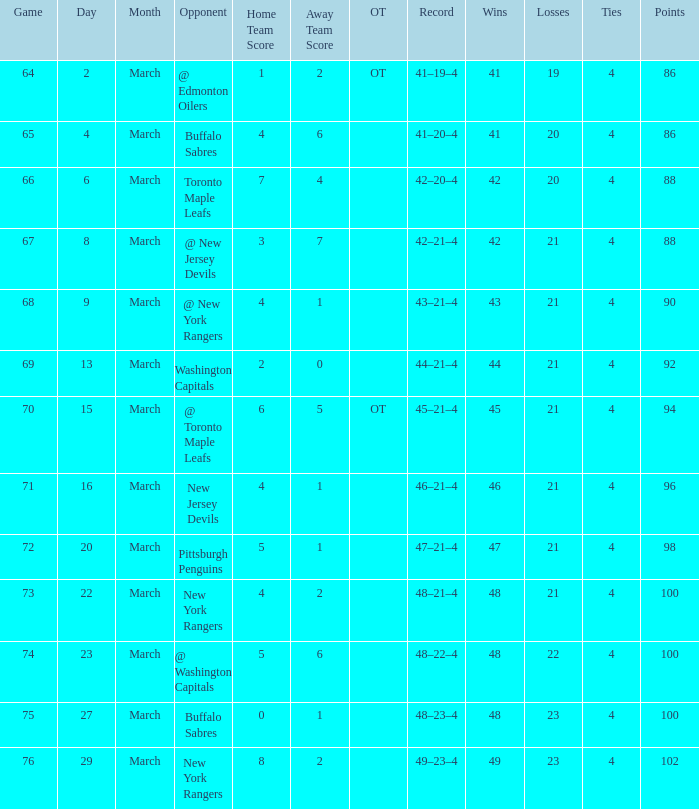Which Score has a March larger than 15, and Points larger than 96, and a Game smaller than 76, and an Opponent of @ washington capitals? 5–6. 